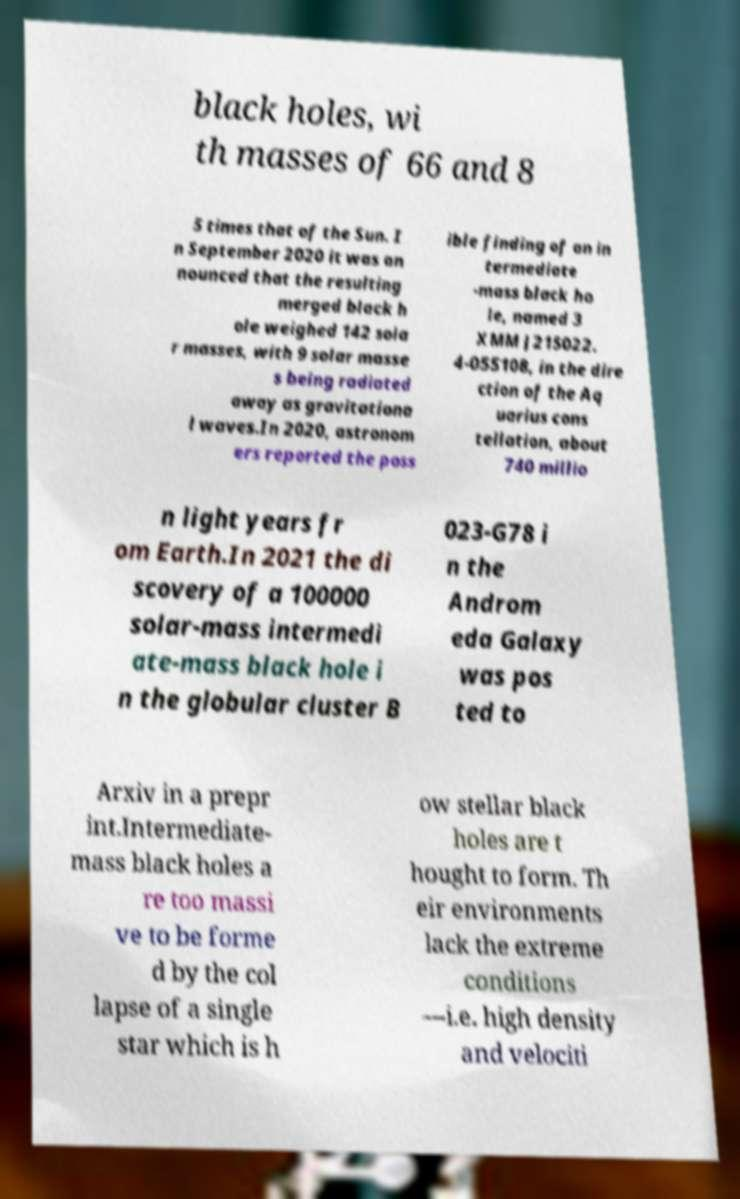Can you accurately transcribe the text from the provided image for me? black holes, wi th masses of 66 and 8 5 times that of the Sun. I n September 2020 it was an nounced that the resulting merged black h ole weighed 142 sola r masses, with 9 solar masse s being radiated away as gravitationa l waves.In 2020, astronom ers reported the poss ible finding of an in termediate -mass black ho le, named 3 XMM J215022. 4-055108, in the dire ction of the Aq uarius cons tellation, about 740 millio n light years fr om Earth.In 2021 the di scovery of a 100000 solar-mass intermedi ate-mass black hole i n the globular cluster B 023-G78 i n the Androm eda Galaxy was pos ted to Arxiv in a prepr int.Intermediate- mass black holes a re too massi ve to be forme d by the col lapse of a single star which is h ow stellar black holes are t hought to form. Th eir environments lack the extreme conditions —i.e. high density and velociti 